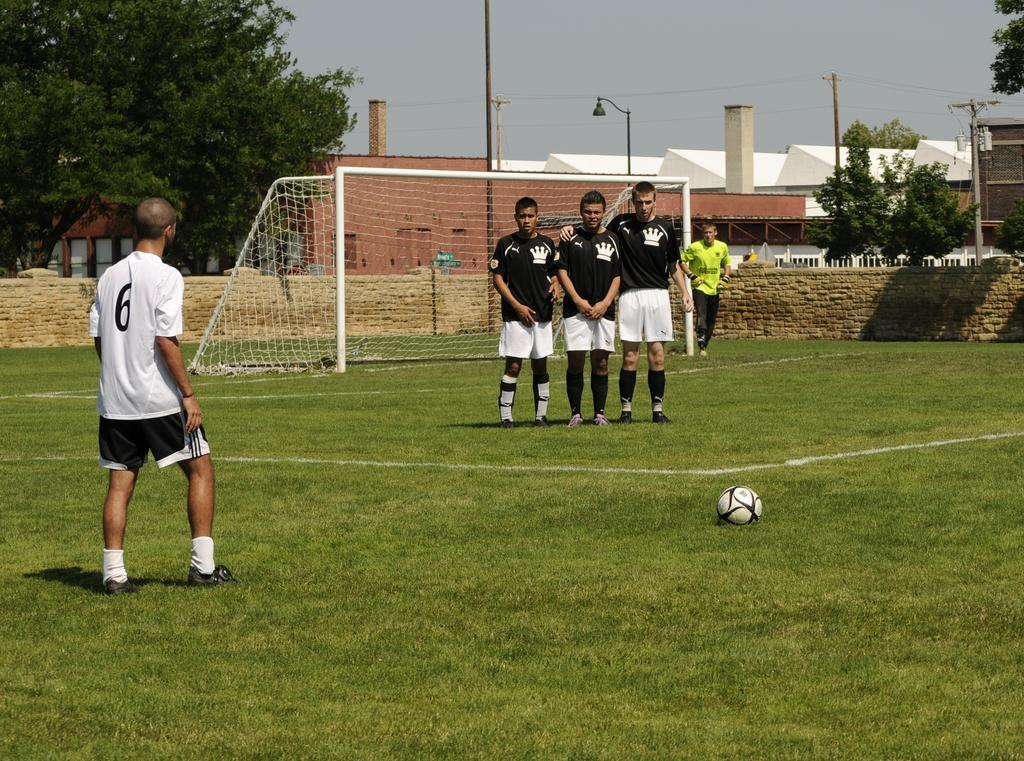How many people are on the ground in the image? There are five persons on the ground in the image. What is the ground covered with? The ground is covered with grass. What object can be seen on the grass? There is a ball on the grass. What can be seen in the background of the image? In the background of the image, there is a mesh, a wall, trees, poles, houses, and the sky. What is the final answer to the question being asked in the image? There is no question being asked in the image, so there is no final answer. How many passengers are visible in the image? There are no passengers visible in the image; it features five persons on the ground. 